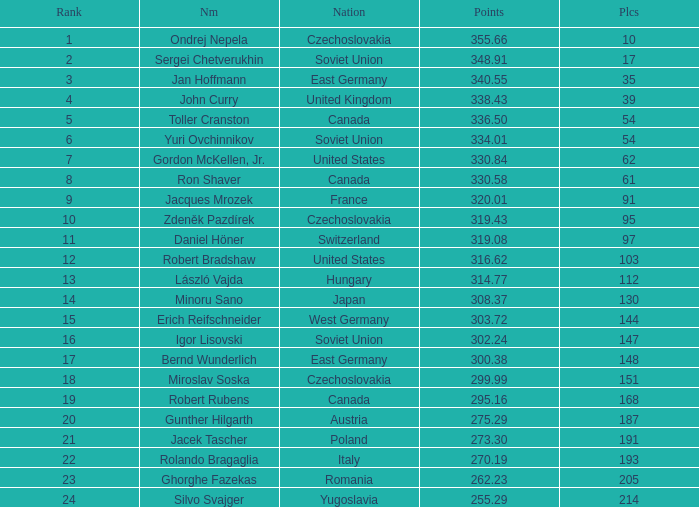Which Nation has Points of 300.38? East Germany. 